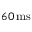<formula> <loc_0><loc_0><loc_500><loc_500>6 0 \, m s</formula> 